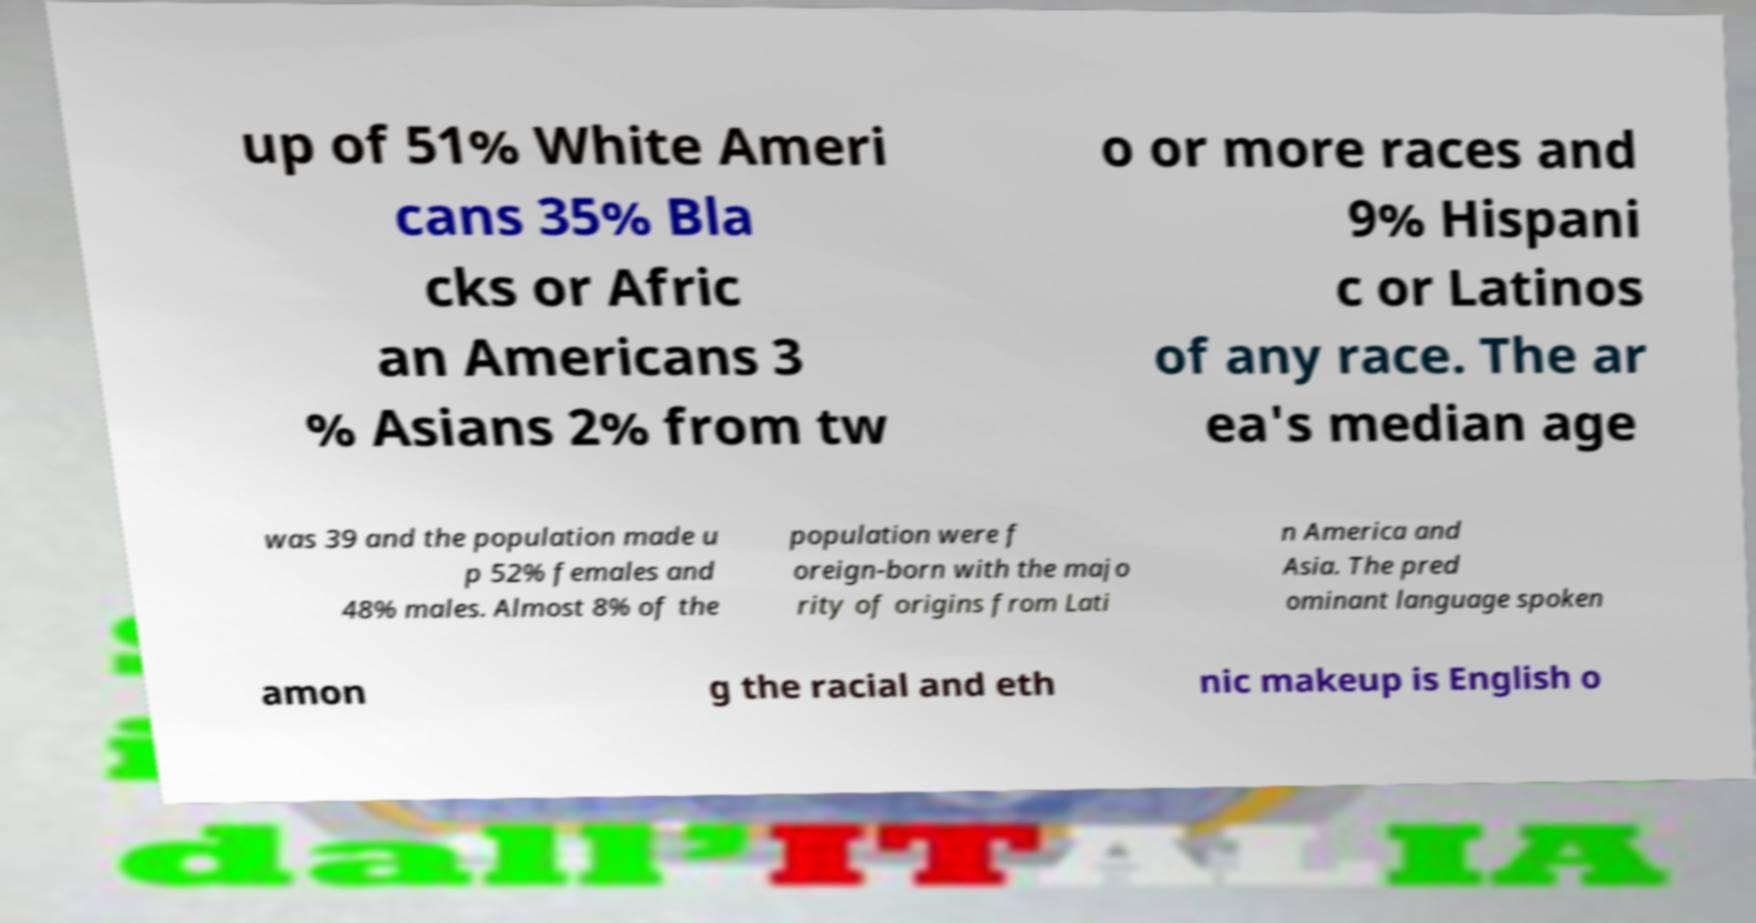Can you accurately transcribe the text from the provided image for me? up of 51% White Ameri cans 35% Bla cks or Afric an Americans 3 % Asians 2% from tw o or more races and 9% Hispani c or Latinos of any race. The ar ea's median age was 39 and the population made u p 52% females and 48% males. Almost 8% of the population were f oreign-born with the majo rity of origins from Lati n America and Asia. The pred ominant language spoken amon g the racial and eth nic makeup is English o 